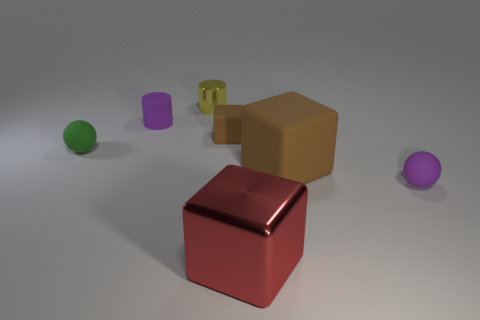How many purple things are behind the tiny green thing and right of the yellow metallic thing?
Your response must be concise. 0. Are there more small green matte balls than purple shiny spheres?
Your answer should be compact. Yes. What is the material of the yellow thing?
Provide a succinct answer. Metal. What number of tiny rubber spheres are to the left of the purple matte thing that is behind the green sphere?
Your answer should be very brief. 1. There is a tiny rubber cylinder; is its color the same as the sphere right of the matte cylinder?
Give a very brief answer. Yes. There is a shiny object that is the same size as the rubber cylinder; what is its color?
Ensure brevity in your answer.  Yellow. Are there any other big matte objects of the same shape as the large red thing?
Provide a short and direct response. Yes. Are there fewer large brown cubes than small purple rubber things?
Keep it short and to the point. Yes. There is a ball in front of the tiny green matte ball; what color is it?
Offer a terse response. Purple. What is the shape of the small purple thing in front of the large thing that is on the right side of the red shiny cube?
Give a very brief answer. Sphere. 